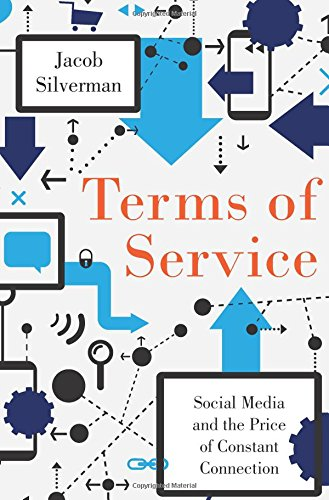Is this book related to Mystery, Thriller & Suspense? No, this book is not related to the Mystery, Thriller & Suspense genres. It is primarily concerned with social media's role and effects in modern society within a technological context. 